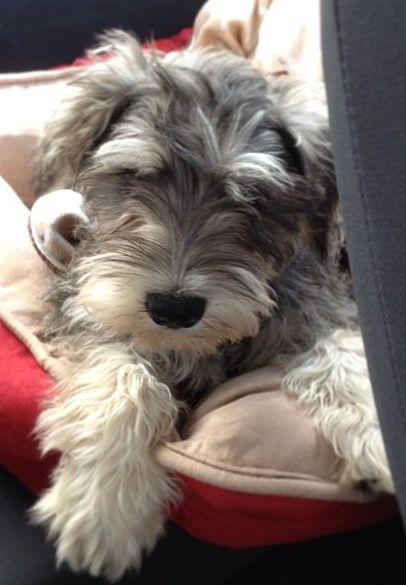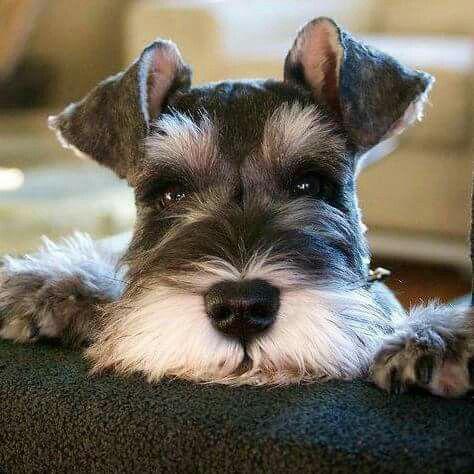The first image is the image on the left, the second image is the image on the right. Examine the images to the left and right. Is the description "An image shows a frontward-facing schnauzer wearing a collar." accurate? Answer yes or no. No. 